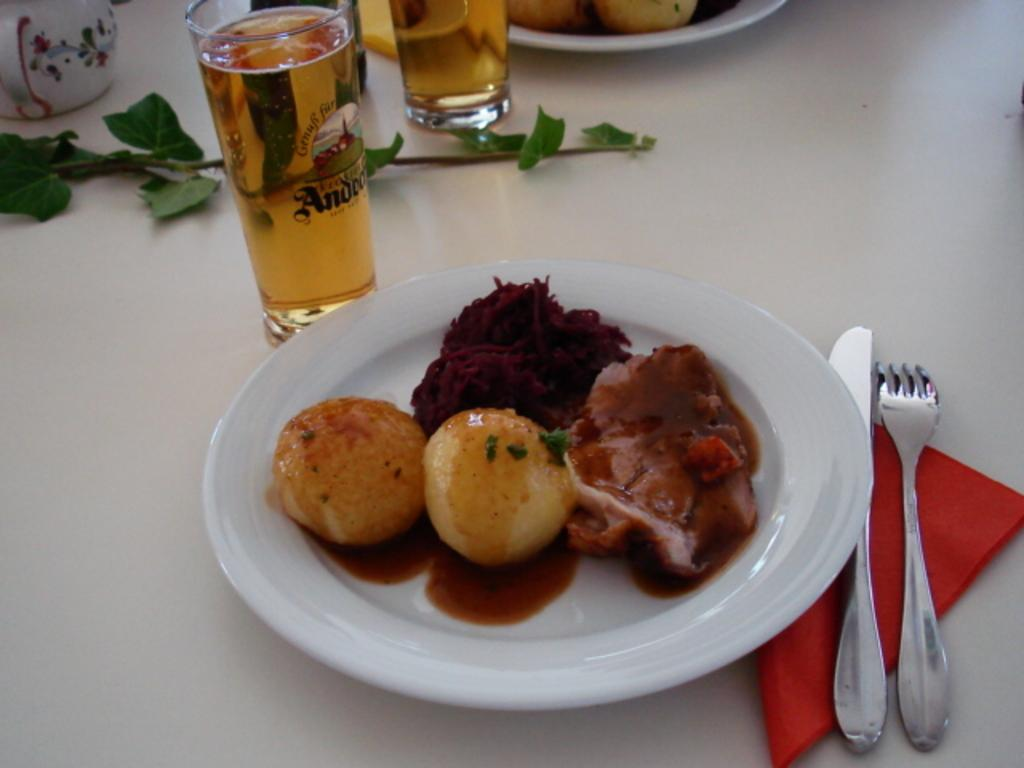What objects are present on the table in the image? There are plates, food items, glasses with liquid, utensils (fork and knife), and a cloth in the image. What might be used to eat the food items on the plates? The utensils (fork and knife) in the image can be used to eat the food items. What is the purpose of the glasses with liquid? The glasses with liquid are likely for drinking. What type of material might the cloth be made of? The cloth could be made of various materials, such as cotton or linen. Can you see any cobwebs in the image? There is no mention of cobwebs in the image, so we cannot determine if they are present or not. What is the rate of consumption for the food items on the plates? The rate of consumption for the food items cannot be determined from the image alone. 